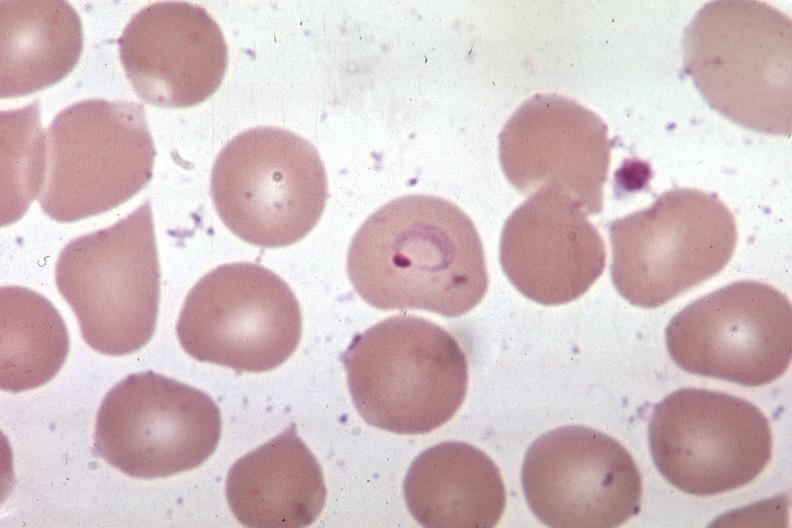s aldehyde fuscin present?
Answer the question using a single word or phrase. No 